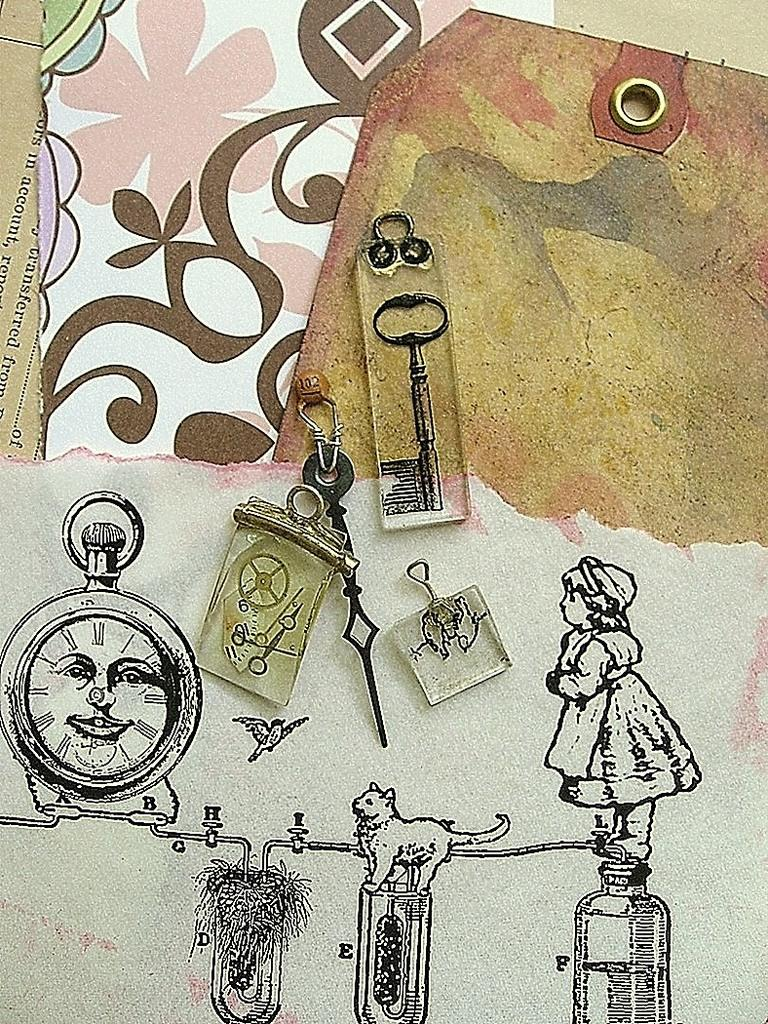What is the main subject of the sketch in the image? The main subject of the sketch in the image is keychains. What specific elements can be seen within the keychains? There is a face in a locket and a cat depicted in the sketch. Are there any human figures in the sketch? Yes, there is a girl depicted in the sketch. How many pies are being held by the girl in the sketch? There are no pies present in the sketch; the girl is not holding any pies. What type of wound can be seen on the cat in the sketch? There is no wound visible on the cat in the sketch; the cat appears to be uninjured. 